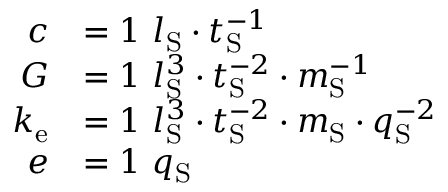Convert formula to latex. <formula><loc_0><loc_0><loc_500><loc_500>{ \begin{array} { r l } { c } & { = 1 \ l _ { S } \cdot t _ { S } ^ { - 1 } } \\ { G } & { = 1 \ l _ { S } ^ { 3 } \cdot t _ { S } ^ { - 2 } \cdot m _ { S } ^ { - 1 } } \\ { k _ { e } } & { = 1 \ l _ { S } ^ { 3 } \cdot t _ { S } ^ { - 2 } \cdot m _ { S } \cdot q _ { S } ^ { - 2 } } \\ { e } & { = 1 \ q _ { S } } \end{array} }</formula> 